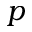<formula> <loc_0><loc_0><loc_500><loc_500>p</formula> 